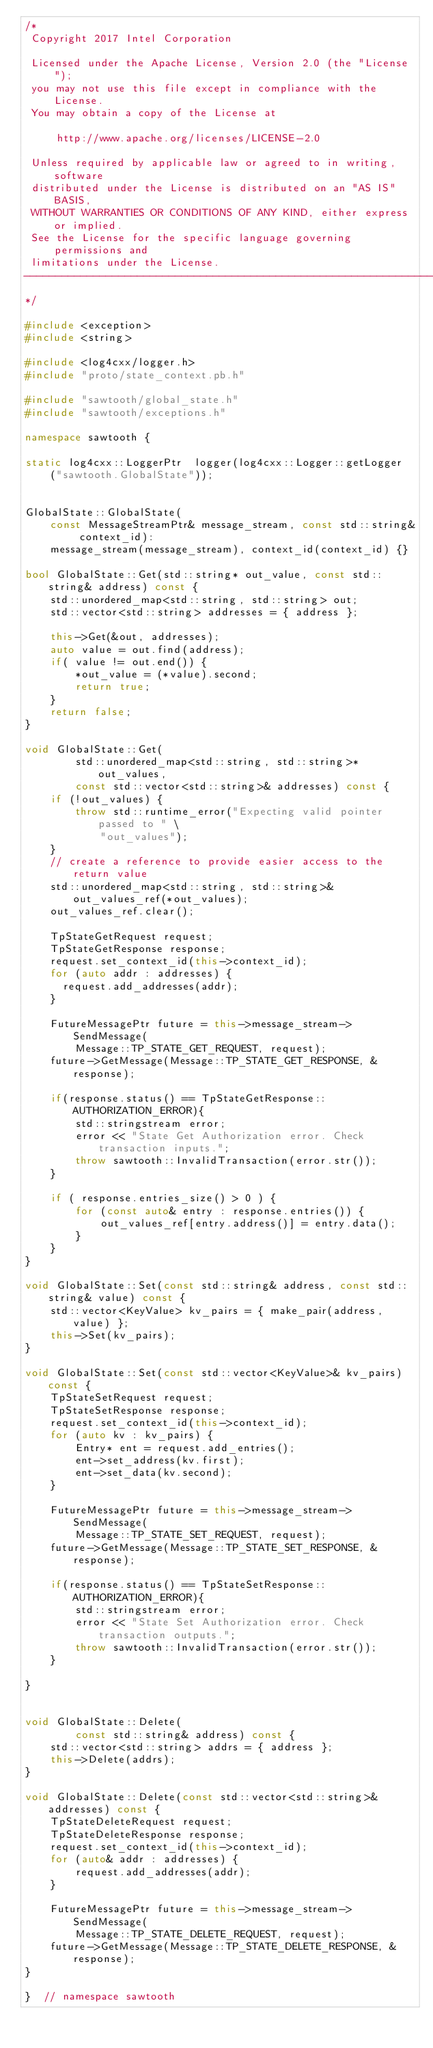<code> <loc_0><loc_0><loc_500><loc_500><_C++_>/*
 Copyright 2017 Intel Corporation

 Licensed under the Apache License, Version 2.0 (the "License");
 you may not use this file except in compliance with the License.
 You may obtain a copy of the License at

     http://www.apache.org/licenses/LICENSE-2.0

 Unless required by applicable law or agreed to in writing, software
 distributed under the License is distributed on an "AS IS" BASIS,
 WITHOUT WARRANTIES OR CONDITIONS OF ANY KIND, either express or implied.
 See the License for the specific language governing permissions and
 limitations under the License.
------------------------------------------------------------------------------
*/

#include <exception>
#include <string>

#include <log4cxx/logger.h>
#include "proto/state_context.pb.h"

#include "sawtooth/global_state.h"
#include "sawtooth/exceptions.h"

namespace sawtooth {

static log4cxx::LoggerPtr  logger(log4cxx::Logger::getLogger
    ("sawtooth.GlobalState"));


GlobalState::GlobalState(
    const MessageStreamPtr& message_stream, const std::string& context_id):
    message_stream(message_stream), context_id(context_id) {}

bool GlobalState::Get(std::string* out_value, const std::string& address) const {
    std::unordered_map<std::string, std::string> out;
    std::vector<std::string> addresses = { address };

    this->Get(&out, addresses);
    auto value = out.find(address);
    if( value != out.end()) {
        *out_value = (*value).second;
        return true;
    }
    return false;
}

void GlobalState::Get(
        std::unordered_map<std::string, std::string>* out_values,
        const std::vector<std::string>& addresses) const {
    if (!out_values) {
        throw std::runtime_error("Expecting valid pointer passed to " \
            "out_values");
    }
    // create a reference to provide easier access to the return value
    std::unordered_map<std::string, std::string>& out_values_ref(*out_values);
    out_values_ref.clear();

    TpStateGetRequest request;
    TpStateGetResponse response;
    request.set_context_id(this->context_id);
    for (auto addr : addresses) {
      request.add_addresses(addr);
    }

    FutureMessagePtr future = this->message_stream->SendMessage(
        Message::TP_STATE_GET_REQUEST, request);
    future->GetMessage(Message::TP_STATE_GET_RESPONSE, &response);

    if(response.status() == TpStateGetResponse::AUTHORIZATION_ERROR){
        std::stringstream error;
        error << "State Get Authorization error. Check transaction inputs.";
        throw sawtooth::InvalidTransaction(error.str());
    }

    if ( response.entries_size() > 0 ) {
        for (const auto& entry : response.entries()) {
            out_values_ref[entry.address()] = entry.data();
        }
    }
}

void GlobalState::Set(const std::string& address, const std::string& value) const {
    std::vector<KeyValue> kv_pairs = { make_pair(address, value) };
    this->Set(kv_pairs);
}

void GlobalState::Set(const std::vector<KeyValue>& kv_pairs) const {
    TpStateSetRequest request;
    TpStateSetResponse response;
    request.set_context_id(this->context_id);
    for (auto kv : kv_pairs) {
        Entry* ent = request.add_entries();
        ent->set_address(kv.first);
        ent->set_data(kv.second);
    }

    FutureMessagePtr future = this->message_stream->SendMessage(
        Message::TP_STATE_SET_REQUEST, request);
    future->GetMessage(Message::TP_STATE_SET_RESPONSE, &response);

    if(response.status() == TpStateSetResponse::AUTHORIZATION_ERROR){
        std::stringstream error;
        error << "State Set Authorization error. Check transaction outputs.";
        throw sawtooth::InvalidTransaction(error.str());
    }

}


void GlobalState::Delete(
        const std::string& address) const {
    std::vector<std::string> addrs = { address };
    this->Delete(addrs);
}

void GlobalState::Delete(const std::vector<std::string>& addresses) const {
    TpStateDeleteRequest request;
    TpStateDeleteResponse response;
    request.set_context_id(this->context_id);
    for (auto& addr : addresses) {
        request.add_addresses(addr);
    }

    FutureMessagePtr future = this->message_stream->SendMessage(
        Message::TP_STATE_DELETE_REQUEST, request);
    future->GetMessage(Message::TP_STATE_DELETE_RESPONSE, &response);
}

}  // namespace sawtooth

</code> 